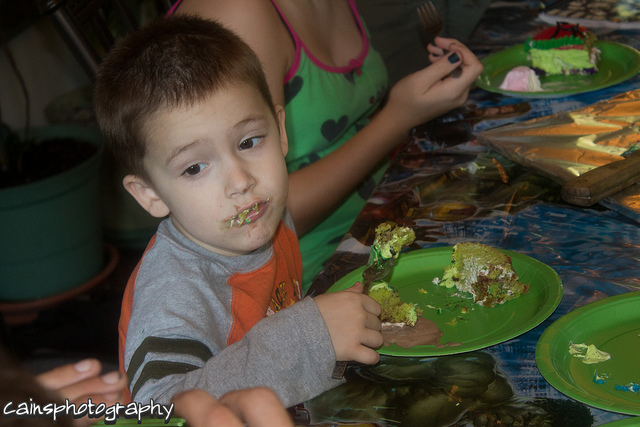Identify the text contained in this image. cainsphotography 7 